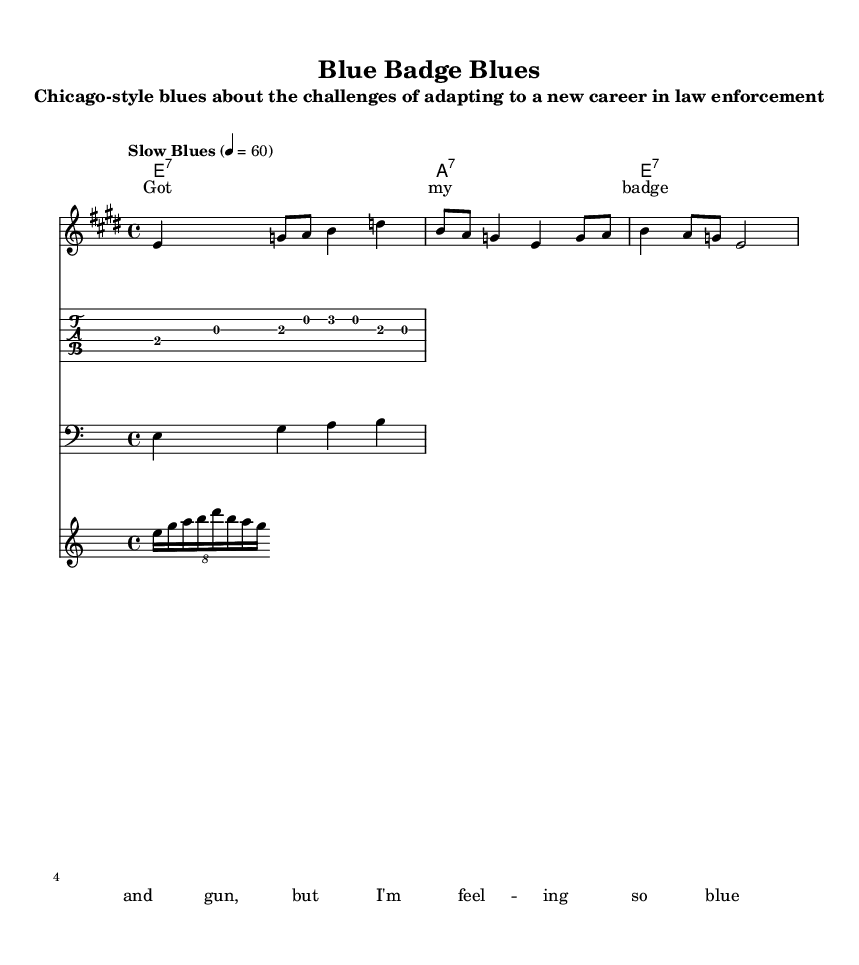What is the key signature of this music? The key signature indicated at the beginning of the sheet music shows two sharps, which indicates that the music is in E major.
Answer: E major What is the time signature for this piece? The time signature at the start of the sheet music is 4/4, meaning there are four beats per measure and the quarter note gets one beat.
Answer: 4/4 What is the tempo marking for this piece? The tempo marking is written as "Slow Blues" and indicates a tempo of 60 beats per minute, which is typical for a blues style.
Answer: Slow Blues, 60 How many measures are in the melody section? The melody section is comprised of three measures, as can be seen from the notation in the melody staff.
Answer: 3 What is the primary chord progression used in the harmonies? The harmonies show a simple blues progression consisting of E7, A7, and back to E7, which is standard for Chicago-style blues.
Answer: E7, A7, E7 What type of instrument is used for the guitar riff? The traditional notation used for the guitar staff indicates that the guitar plays the riff, typical for blues music, providing a rhythmic and harmonic foundation.
Answer: Guitar Which musical element indicates improvisation typically found in blues? The harmonica fill consists of a tuplet rhythm, which suggests a spontaneous, improvisational style that is common in blues music.
Answer: Harmonica fill 